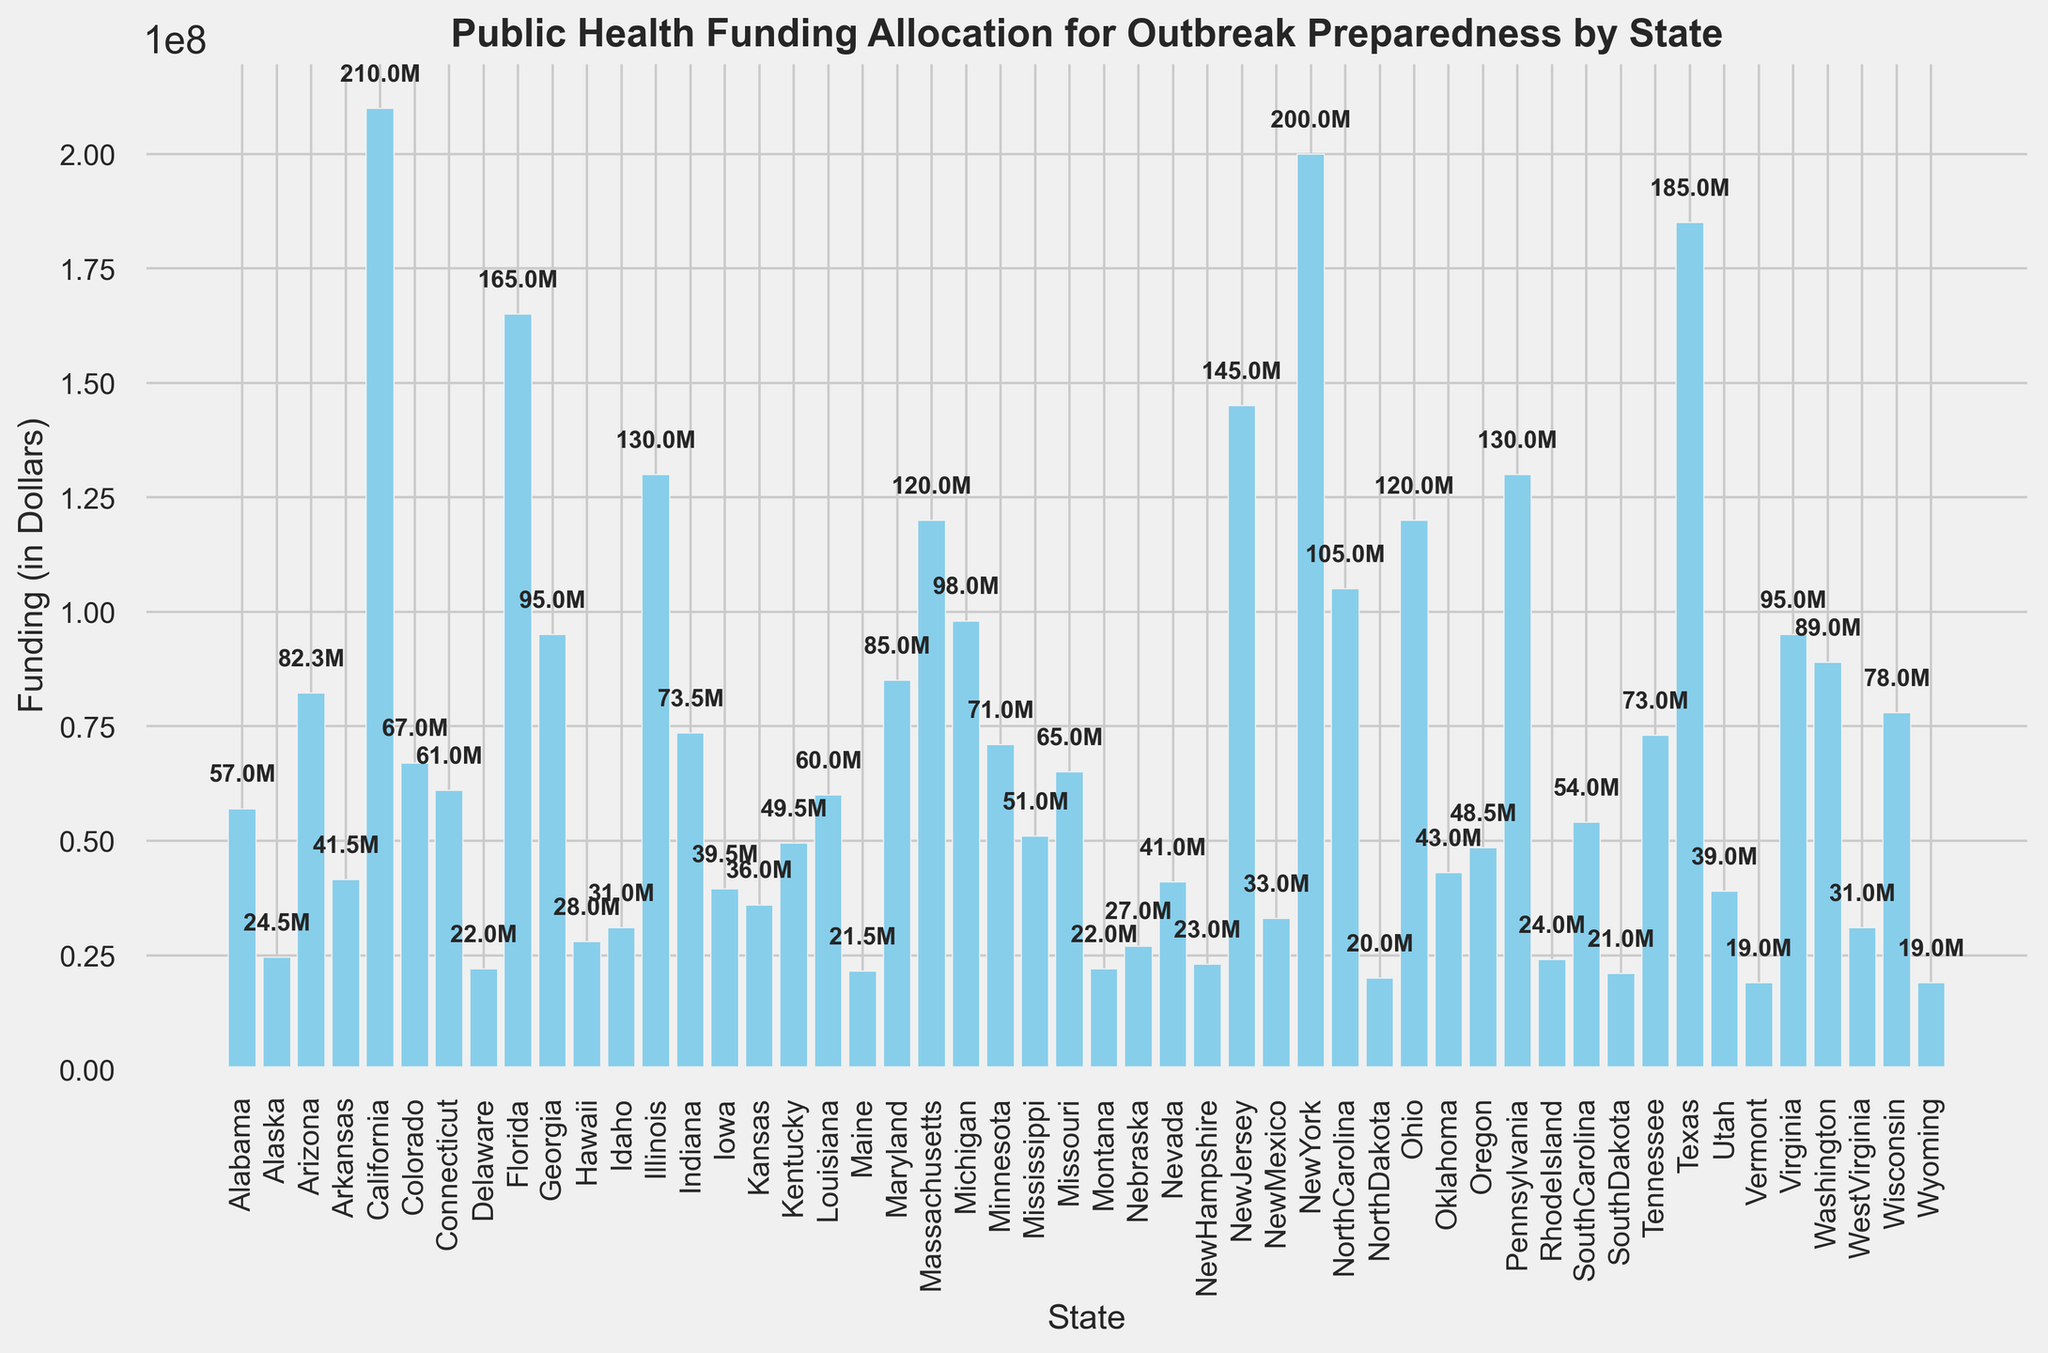Which state received the highest funding for outbreak preparedness? The state with the tallest bar on the bar chart indicates the highest funding. California has the highest bar, showing it received the most funding.
Answer: California Which state received the lowest funding for outbreak preparedness? The state with the shortest bar on the bar chart indicates the lowest funding. Vermont and Wyoming have the shortest bars.
Answer: Vermont and Wyoming How does the funding for Texas compare to that of New York? To compare the funding amounts, we observe the heights of the bars for Texas and New York. The bar for Texas is slightly taller than the bar for New York.
Answer: Texas received higher funding than New York What is the total funding received by Florida, Illinois, and Pennsylvania? Initially, identify the funding amounts for Florida (165,000,000), Illinois (130,000,000), and Pennsylvania (130,000,000). Then, sum these amounts: 165,000,000 + 130,000,000 + 130,000,000.
Answer: 425,000,000 Which states have funding amounts close to 50 million dollars? Look for bars with heights around 50 million. The states closest to 50 million dollars are Kentucky (49,500,000), Mississippi (51,000,000), and South Carolina (54,000,000).
Answer: Kentucky, Mississippi, and South Carolina What is the combined funding received by the states with less than 30 million dollars each? Identify the states with funding < 30,000,000: Alaska (24,500,000), Delaware (22,000,000), Hawaii (28,000,000), Idaho (31,000,000), Maine (21,500,000), Montana (22,000,000), Nebraska (27,000,000), New Hampshire (23,000,000), North Dakota (20,000,000), Rhode Island (24,000,000), South Dakota (21,000,000), Vermont (19,000,000), West Virginia (31,000,000), and Wyoming (19,000,000). Sum these amounts.
Answer: 292,000,000 What is the average funding allocated per state? Sum all the states' funding and divide by the number of states (50). First, sum all the provided funding amounts, then divide by 50: (57000000 + 24500000 + 82300000 + ... + 19000000) / 50.
Answer: 66,360,000 Which region (states from the top or bottom half of the bar chart) generally receives more funding? Visually compare the median funding state (Minnesota) to identify the states' median division line. States above (e.g., California, Texas) generally receive more funding than those below (e.g., Hawaii, Delaware).
Answer: Top half If Vermont received the same funding as Kansas, what would be the total funding for Vermont and Kansas combined? If Vermont (currently 19 million) received Kansas’s funding (36 million), Vermont's total would be 36 million. Then sum the two amounts: Kansas's funding + Vermont's new funding = 36,000,000 + 36,000,000.
Answer: 72,000,000 How does Washington's public health funding compare to the average funding per state? First, compute Washington's allocation (89,000,000). Then, compare it to the average found (66,360,000). Washington’s funding is higher than the average.
Answer: Washington's funding is higher than the average 